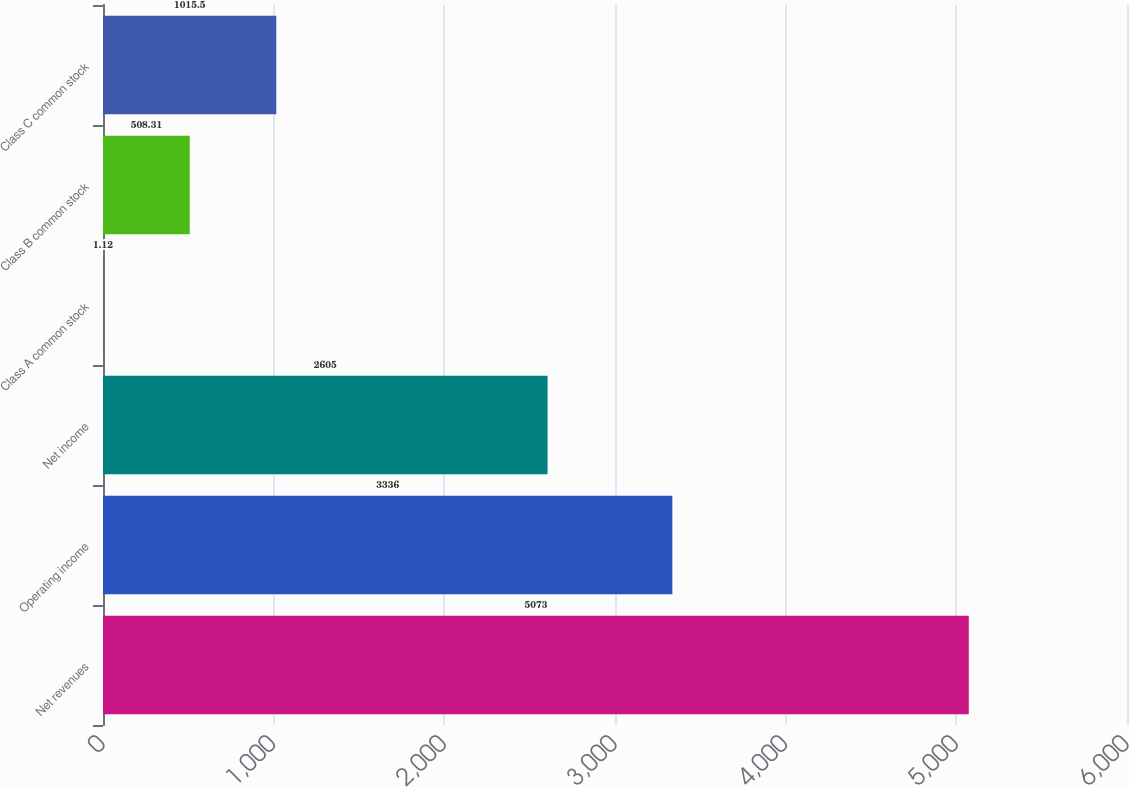Convert chart to OTSL. <chart><loc_0><loc_0><loc_500><loc_500><bar_chart><fcel>Net revenues<fcel>Operating income<fcel>Net income<fcel>Class A common stock<fcel>Class B common stock<fcel>Class C common stock<nl><fcel>5073<fcel>3336<fcel>2605<fcel>1.12<fcel>508.31<fcel>1015.5<nl></chart> 